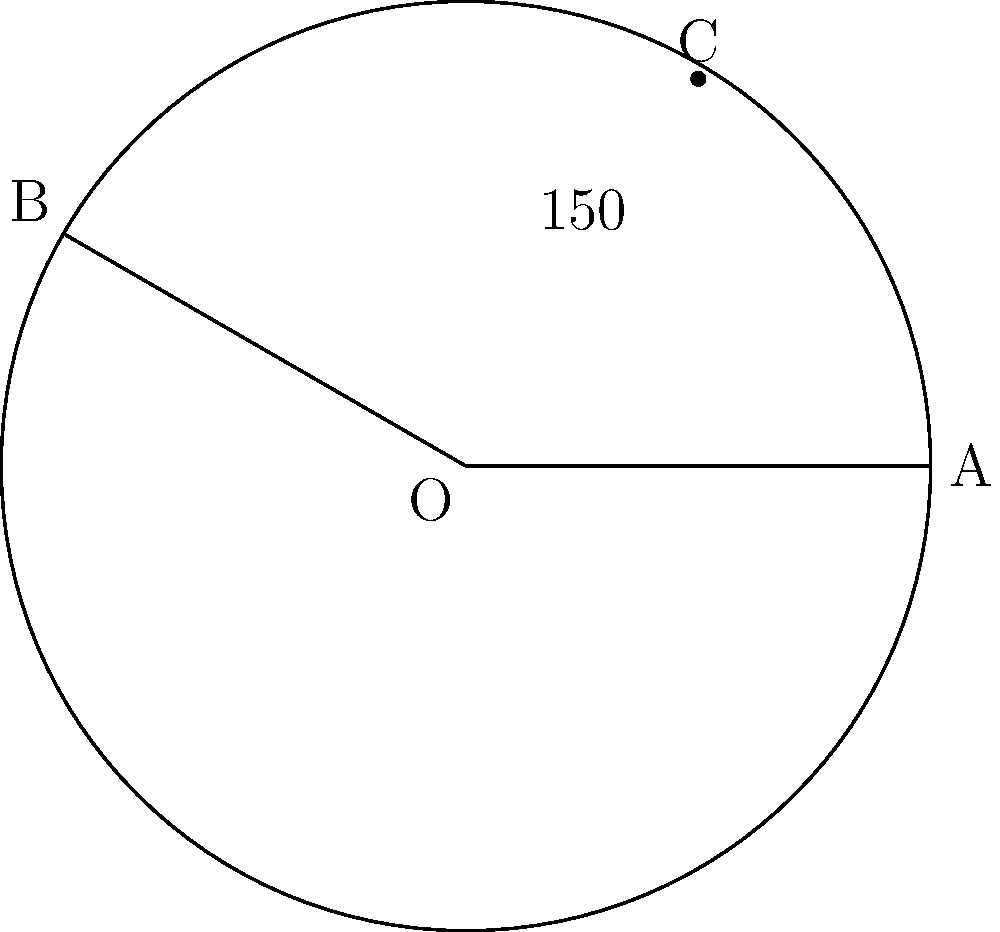As part of a trauma-informed program for students, you're planning a series of workshops. The circle represents the total duration of the program, with each degree corresponding to 1 hour. If the arc AB spans 150°, how many hours long is this segment of the program? To solve this problem, we need to calculate the arc length of the circle segment represented by the 150° angle. Here's how we can do it step-by-step:

1) First, recall the formula for arc length:
   $s = \frac{\theta}{360°} \cdot 2\pi r$

   Where:
   $s$ is the arc length
   $\theta$ is the central angle in degrees
   $r$ is the radius of the circle

2) In this case, we're told that each degree corresponds to 1 hour. This means we don't need to use the actual radius of the circle. Instead, we can simply use the proportion of the circle represented by the angle.

3) The proportion of the circle is:
   $\frac{150°}{360°} = \frac{5}{12}$

4) Since the full circle (360°) represents the total duration of the program, and each degree is 1 hour, the segment length in hours is simply:

   $\text{Hours} = \frac{150°}{360°} \cdot 360 = 150$

Therefore, this segment of the program is 150 hours long.
Answer: 150 hours 